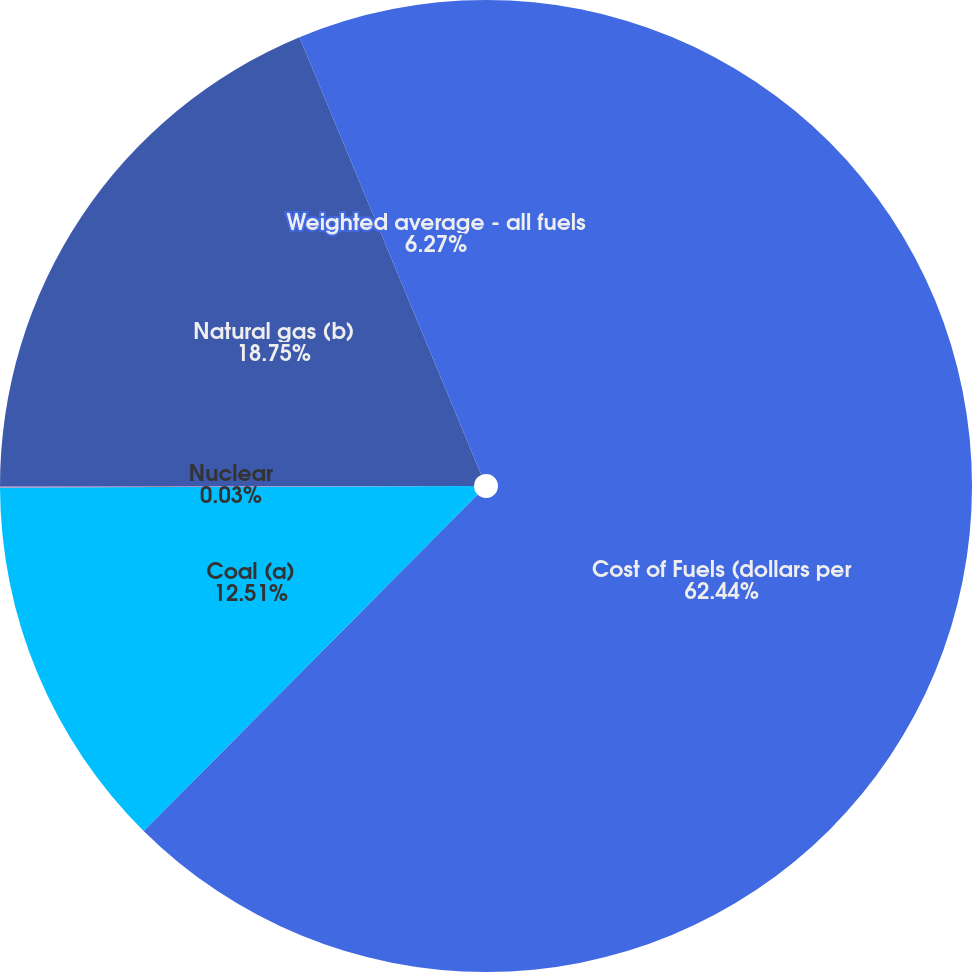<chart> <loc_0><loc_0><loc_500><loc_500><pie_chart><fcel>Cost of Fuels (dollars per<fcel>Coal (a)<fcel>Nuclear<fcel>Natural gas (b)<fcel>Weighted average - all fuels<nl><fcel>62.44%<fcel>12.51%<fcel>0.03%<fcel>18.75%<fcel>6.27%<nl></chart> 